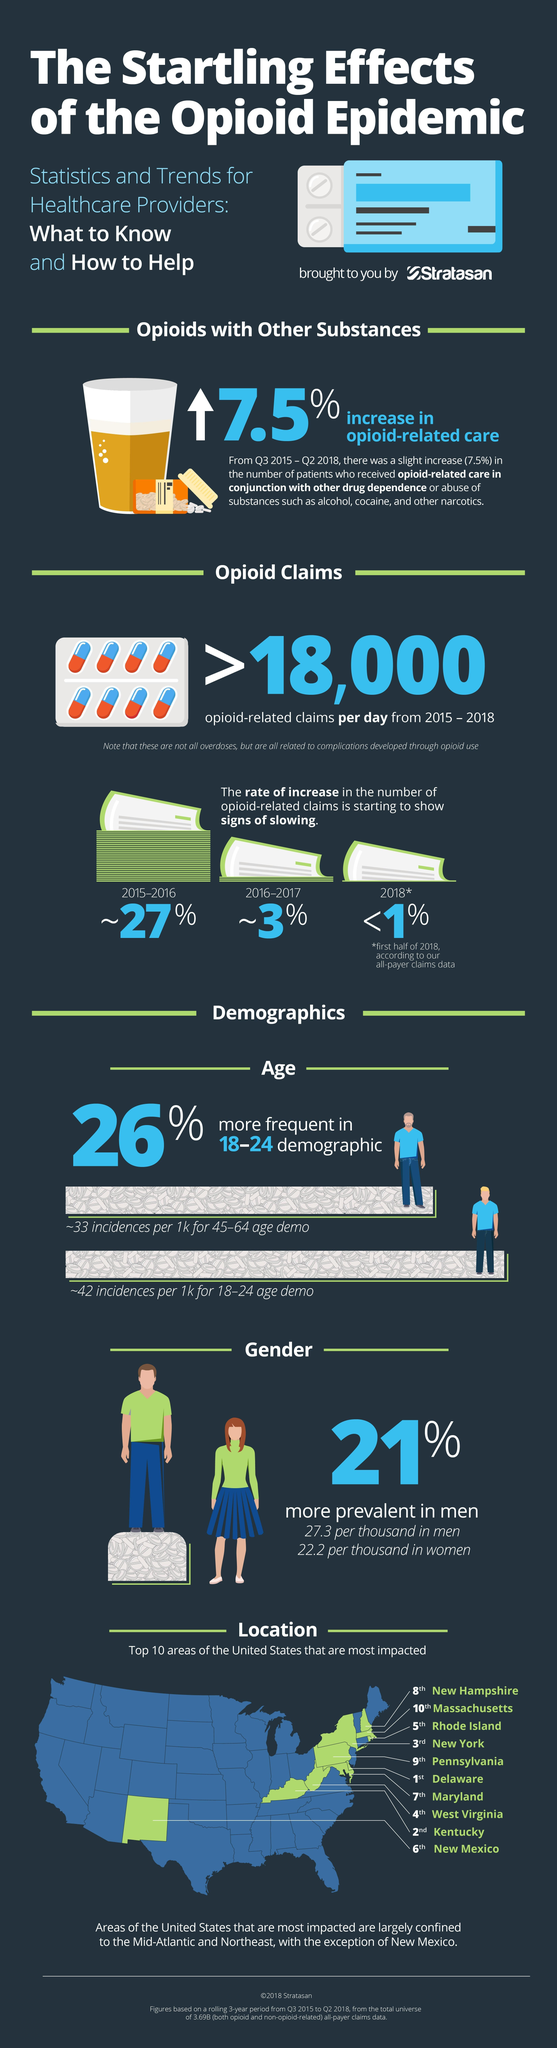Which year shows the lowest claims due to opioid?
Answer the question with a short phrase. 2018 What is the difference in incidences between the age groups 18-24 and 45-64? 9 